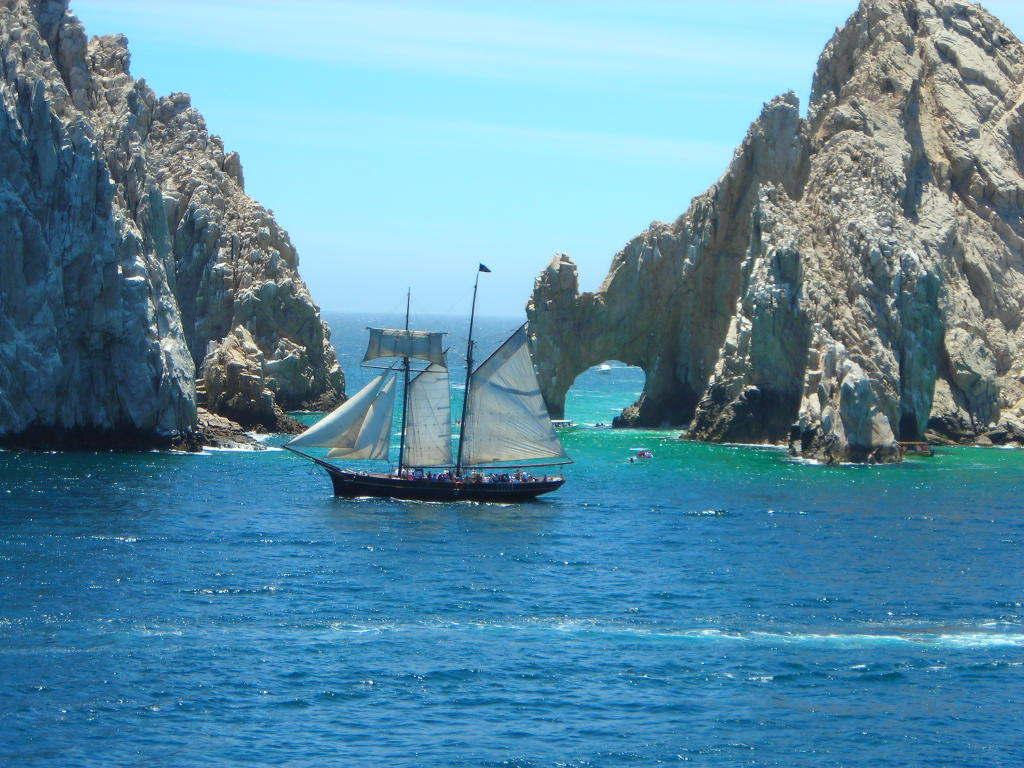What is the main subject of the image? The main subject of the image is a boat. What is the boat doing in the image? The boat is moving on the water in the image. What can be seen on both sides of the image? There are hills on both the left and right sides of the image. What is visible at the top of the image? The sky is visible at the top of the image. How many matches are visible in the image? There are no matches present in the image. What type of pollution can be seen in the image? There is no pollution visible in the image. 